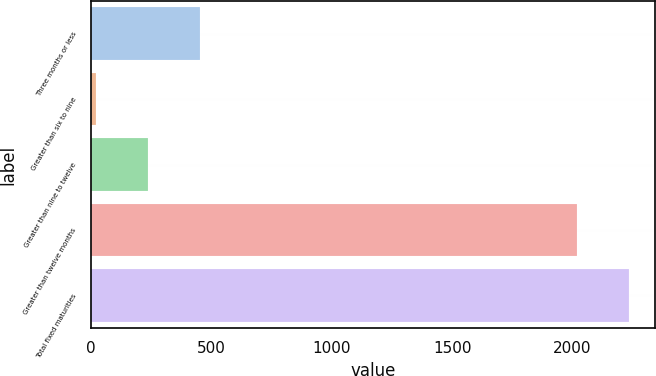Convert chart. <chart><loc_0><loc_0><loc_500><loc_500><bar_chart><fcel>Three months or less<fcel>Greater than six to nine<fcel>Greater than nine to twelve<fcel>Greater than twelve months<fcel>Total fixed maturities<nl><fcel>453.72<fcel>22.6<fcel>238.16<fcel>2016.8<fcel>2232.36<nl></chart> 